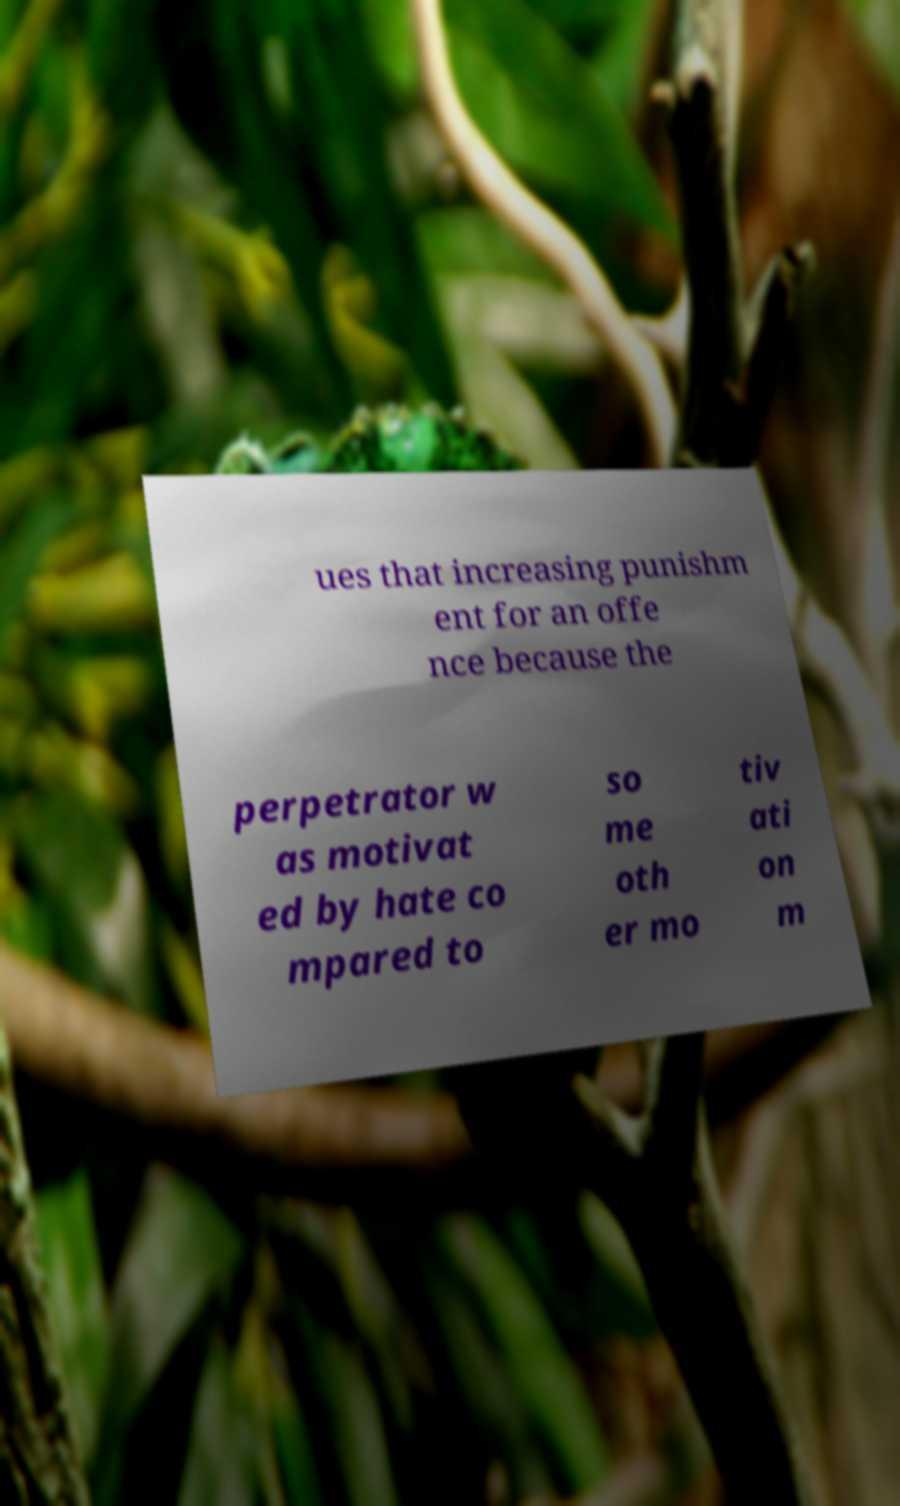There's text embedded in this image that I need extracted. Can you transcribe it verbatim? ues that increasing punishm ent for an offe nce because the perpetrator w as motivat ed by hate co mpared to so me oth er mo tiv ati on m 